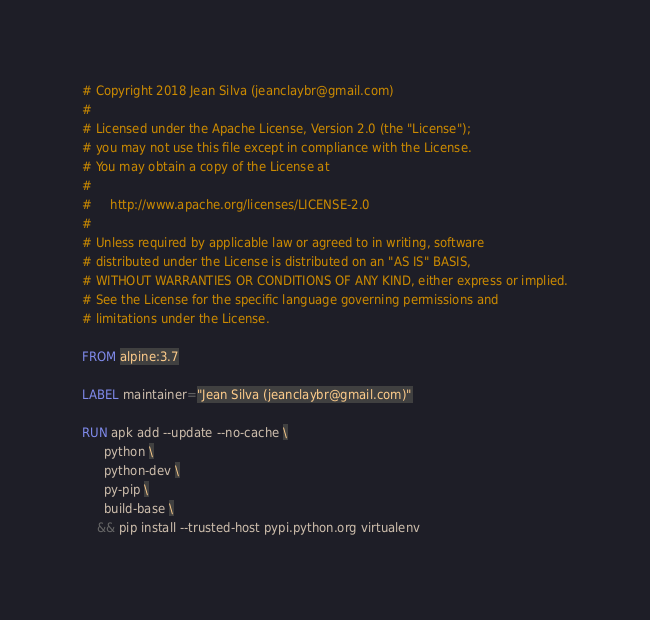Convert code to text. <code><loc_0><loc_0><loc_500><loc_500><_Dockerfile_># Copyright 2018 Jean Silva (jeanclaybr@gmail.com)
#
# Licensed under the Apache License, Version 2.0 (the "License");
# you may not use this file except in compliance with the License.
# You may obtain a copy of the License at
#
#     http://www.apache.org/licenses/LICENSE-2.0
#
# Unless required by applicable law or agreed to in writing, software
# distributed under the License is distributed on an "AS IS" BASIS,
# WITHOUT WARRANTIES OR CONDITIONS OF ANY KIND, either express or implied.
# See the License for the specific language governing permissions and
# limitations under the License.

FROM alpine:3.7

LABEL maintainer="Jean Silva (jeanclaybr@gmail.com)"

RUN apk add --update --no-cache \
      python \
      python-dev \
      py-pip \
      build-base \
    && pip install --trusted-host pypi.python.org virtualenv

</code> 